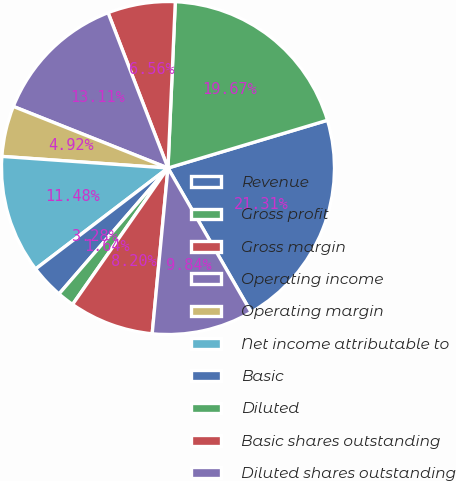<chart> <loc_0><loc_0><loc_500><loc_500><pie_chart><fcel>Revenue<fcel>Gross profit<fcel>Gross margin<fcel>Operating income<fcel>Operating margin<fcel>Net income attributable to<fcel>Basic<fcel>Diluted<fcel>Basic shares outstanding<fcel>Diluted shares outstanding<nl><fcel>21.31%<fcel>19.67%<fcel>6.56%<fcel>13.11%<fcel>4.92%<fcel>11.48%<fcel>3.28%<fcel>1.64%<fcel>8.2%<fcel>9.84%<nl></chart> 